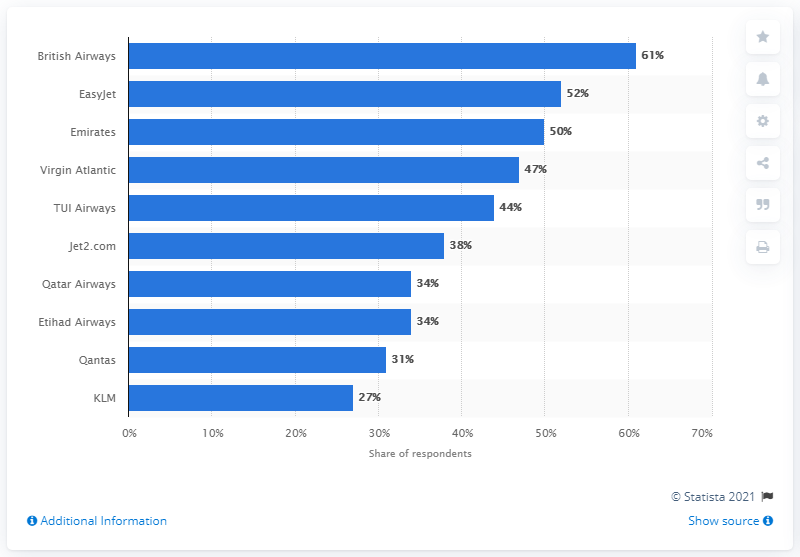Give some essential details in this illustration. According to a survey conducted in 2019, British Airways was the most popular airline among millennials in the UK. 